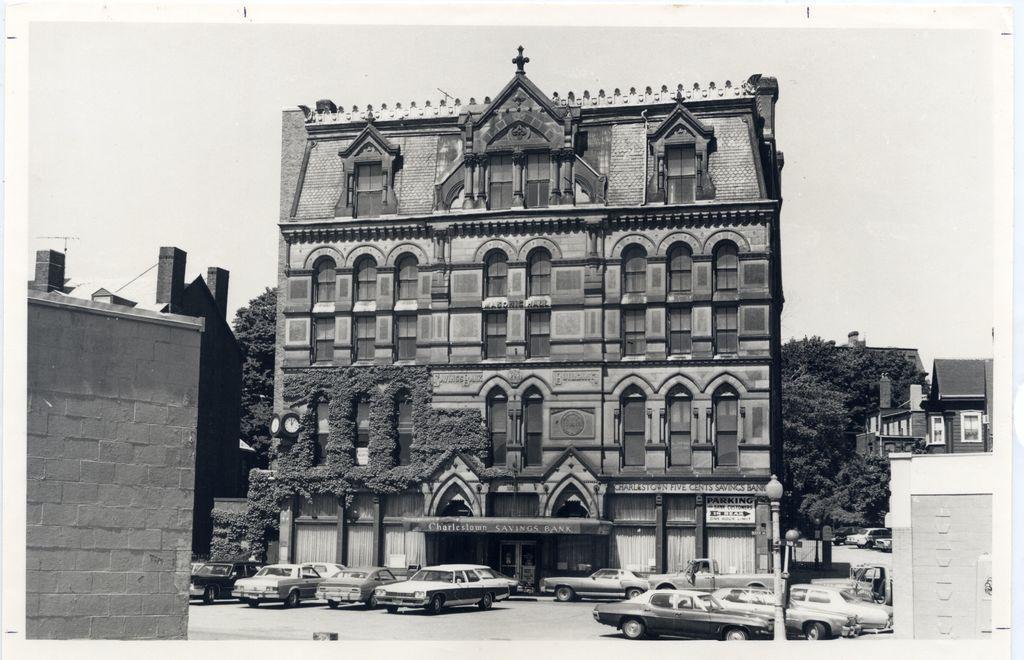Please provide a concise description of this image. In this image I can see the building. In-front of the building there are many cars and I can see the pole. In the background I can see many trees and the sky. 